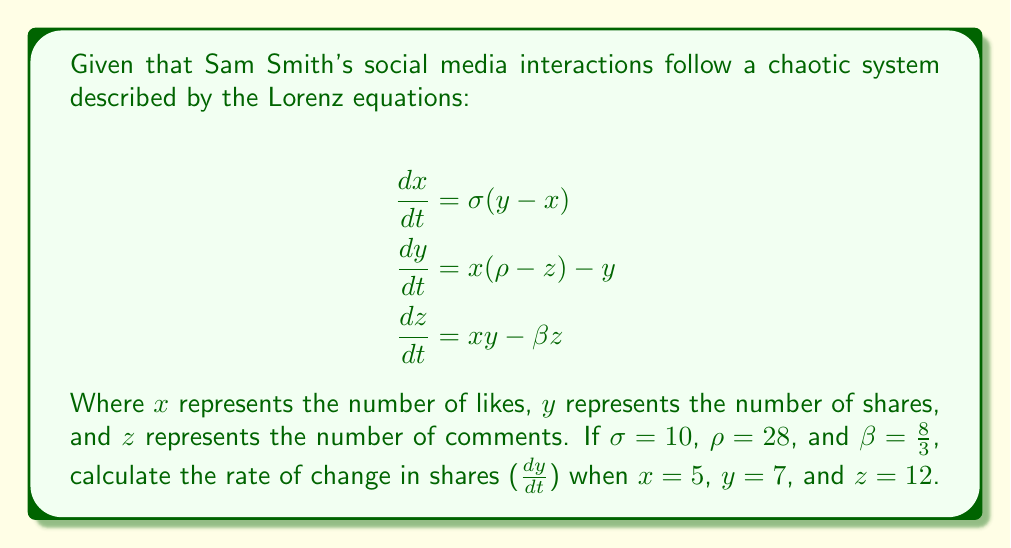Provide a solution to this math problem. To solve this problem, we'll follow these steps:

1. Identify the equation for $\frac{dy}{dt}$:
   $$\frac{dy}{dt} = x(\rho-z) - y$$

2. Substitute the given values:
   - $x = 5$
   - $y = 7$
   - $z = 12$
   - $\rho = 28$

3. Calculate $\rho - z$:
   $28 - 12 = 16$

4. Multiply $x$ by $(\rho - z)$:
   $5 \times 16 = 80$

5. Subtract $y$ from the result:
   $80 - 7 = 73$

6. Therefore, $\frac{dy}{dt} = 73$

This result indicates that at the given point, the rate of change in shares is positive and quite significant, suggesting a rapid increase in the number of shares for Sam Smith's social media post at this particular moment.
Answer: 73 